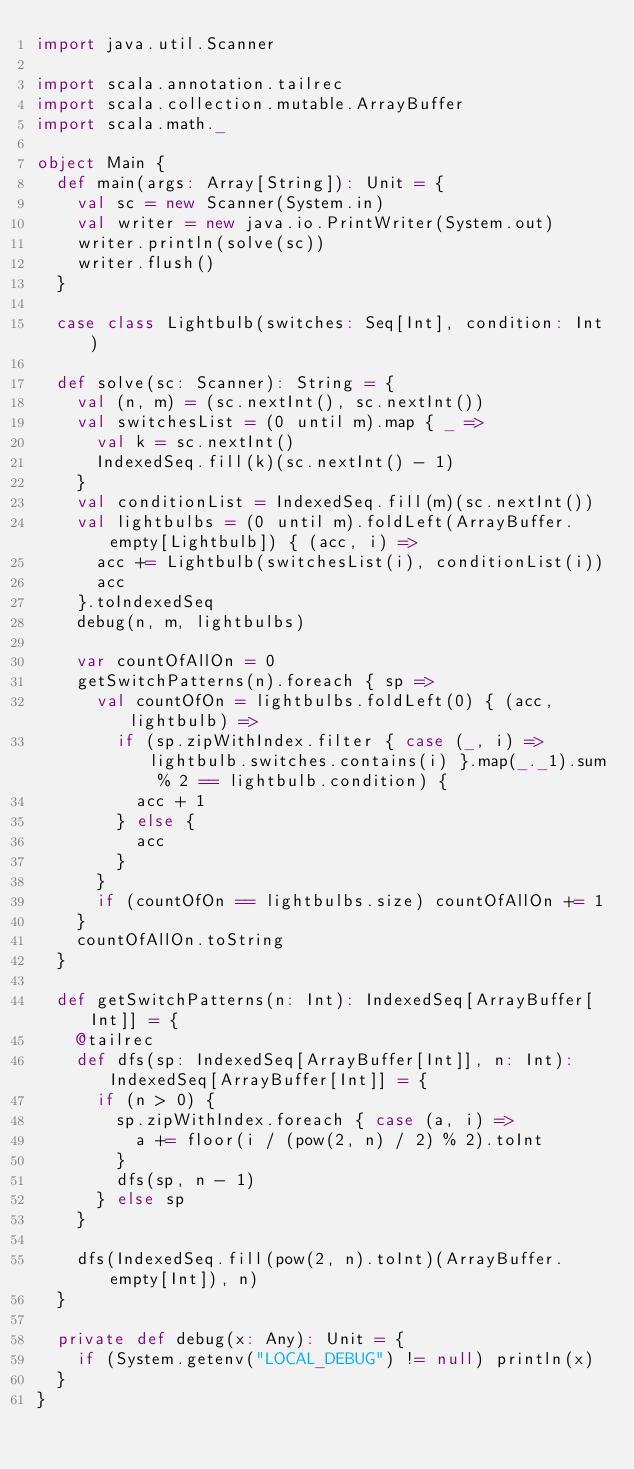<code> <loc_0><loc_0><loc_500><loc_500><_Scala_>import java.util.Scanner

import scala.annotation.tailrec
import scala.collection.mutable.ArrayBuffer
import scala.math._

object Main {
  def main(args: Array[String]): Unit = {
    val sc = new Scanner(System.in)
    val writer = new java.io.PrintWriter(System.out)
    writer.println(solve(sc))
    writer.flush()
  }

  case class Lightbulb(switches: Seq[Int], condition: Int)

  def solve(sc: Scanner): String = {
    val (n, m) = (sc.nextInt(), sc.nextInt())
    val switchesList = (0 until m).map { _ =>
      val k = sc.nextInt()
      IndexedSeq.fill(k)(sc.nextInt() - 1)
    }
    val conditionList = IndexedSeq.fill(m)(sc.nextInt())
    val lightbulbs = (0 until m).foldLeft(ArrayBuffer.empty[Lightbulb]) { (acc, i) =>
      acc += Lightbulb(switchesList(i), conditionList(i))
      acc
    }.toIndexedSeq
    debug(n, m, lightbulbs)

    var countOfAllOn = 0
    getSwitchPatterns(n).foreach { sp =>
      val countOfOn = lightbulbs.foldLeft(0) { (acc, lightbulb) =>
        if (sp.zipWithIndex.filter { case (_, i) => lightbulb.switches.contains(i) }.map(_._1).sum % 2 == lightbulb.condition) {
          acc + 1
        } else {
          acc
        }
      }
      if (countOfOn == lightbulbs.size) countOfAllOn += 1
    }
    countOfAllOn.toString
  }

  def getSwitchPatterns(n: Int): IndexedSeq[ArrayBuffer[Int]] = {
    @tailrec
    def dfs(sp: IndexedSeq[ArrayBuffer[Int]], n: Int): IndexedSeq[ArrayBuffer[Int]] = {
      if (n > 0) {
        sp.zipWithIndex.foreach { case (a, i) =>
          a += floor(i / (pow(2, n) / 2) % 2).toInt
        }
        dfs(sp, n - 1)
      } else sp
    }

    dfs(IndexedSeq.fill(pow(2, n).toInt)(ArrayBuffer.empty[Int]), n)
  }

  private def debug(x: Any): Unit = {
    if (System.getenv("LOCAL_DEBUG") != null) println(x)
  }
}
</code> 